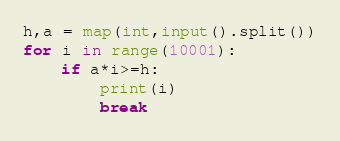<code> <loc_0><loc_0><loc_500><loc_500><_Python_>h,a = map(int,input().split())
for i in range(10001):
    if a*i>=h:
        print(i)
        break
</code> 